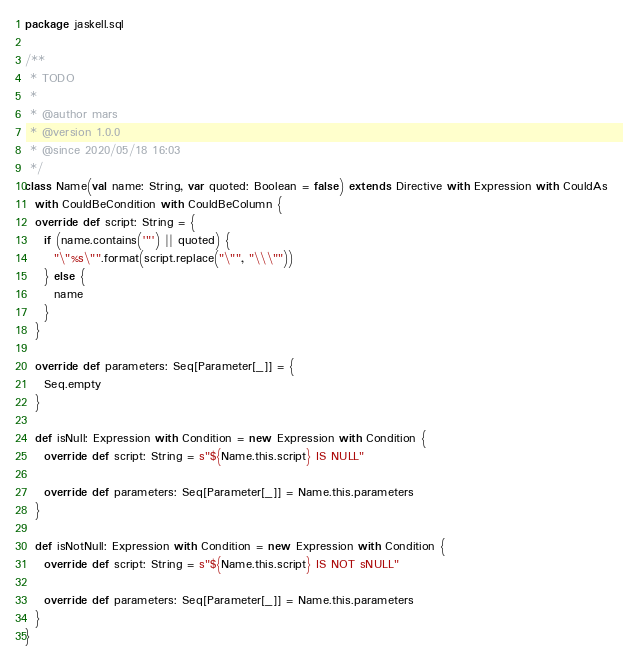<code> <loc_0><loc_0><loc_500><loc_500><_Scala_>package jaskell.sql

/**
 * TODO
 *
 * @author mars
 * @version 1.0.0
 * @since 2020/05/18 16:03
 */
class Name(val name: String, var quoted: Boolean = false) extends Directive with Expression with CouldAs
  with CouldBeCondition with CouldBeColumn {
  override def script: String = {
    if (name.contains('"') || quoted) {
      "\"%s\"".format(script.replace("\"", "\\\""))
    } else {
      name
    }
  }

  override def parameters: Seq[Parameter[_]] = {
    Seq.empty
  }

  def isNull: Expression with Condition = new Expression with Condition {
    override def script: String = s"${Name.this.script} IS NULL"

    override def parameters: Seq[Parameter[_]] = Name.this.parameters
  }

  def isNotNull: Expression with Condition = new Expression with Condition {
    override def script: String = s"${Name.this.script} IS NOT sNULL"

    override def parameters: Seq[Parameter[_]] = Name.this.parameters
  }
}
</code> 